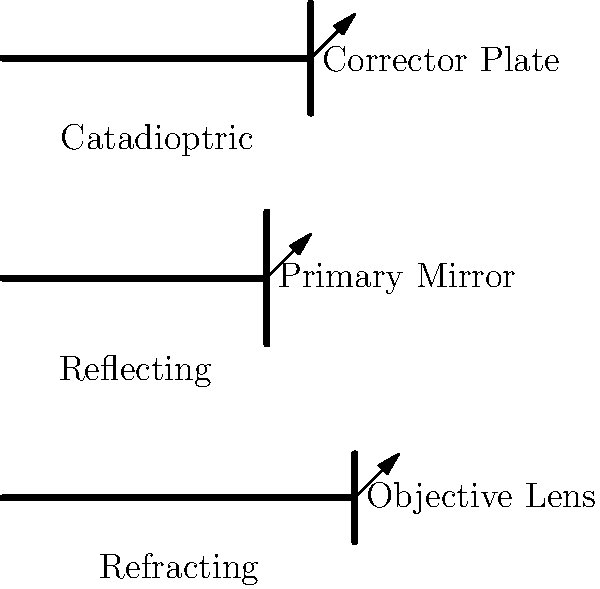As a street vendor who's always on the move, you might appreciate the portability of different telescope designs. Which type of telescope combines the best features of both refracting and reflecting telescopes, making it compact and versatile for urban stargazing? To answer this question, let's break down the characteristics of the three main types of telescopes shown in the diagram:

1. Refracting Telescope:
   - Uses lenses to gather and focus light
   - Typically long and narrow
   - Good for planetary viewing but can be less portable

2. Reflecting Telescope:
   - Uses mirrors to gather and focus light
   - Generally shorter and wider than refractors
   - Good for deep-sky objects but can be bulky

3. Catadioptric Telescope:
   - Combines lenses and mirrors
   - Compact design
   - Versatile for both planetary and deep-sky viewing

The catadioptric telescope, represented in the top position of the diagram, is designed to be more compact while maintaining good optical performance. It uses a corrector plate at the front (shown in the diagram) and a combination of mirrors inside to fold the light path. This design results in a telescope that is shorter and more portable than either a pure refractor or reflector of equivalent aperture.

For a street vendor who needs to be mobile and might want to set up quickly in different urban locations for stargazing, the catadioptric design offers the best compromise between portability and versatility. It's compact enough to carry around easily, yet powerful enough to provide good views of both planets and deep-sky objects, making it ideal for urban astronomy where space and setup time might be limited.
Answer: Catadioptric telescope 